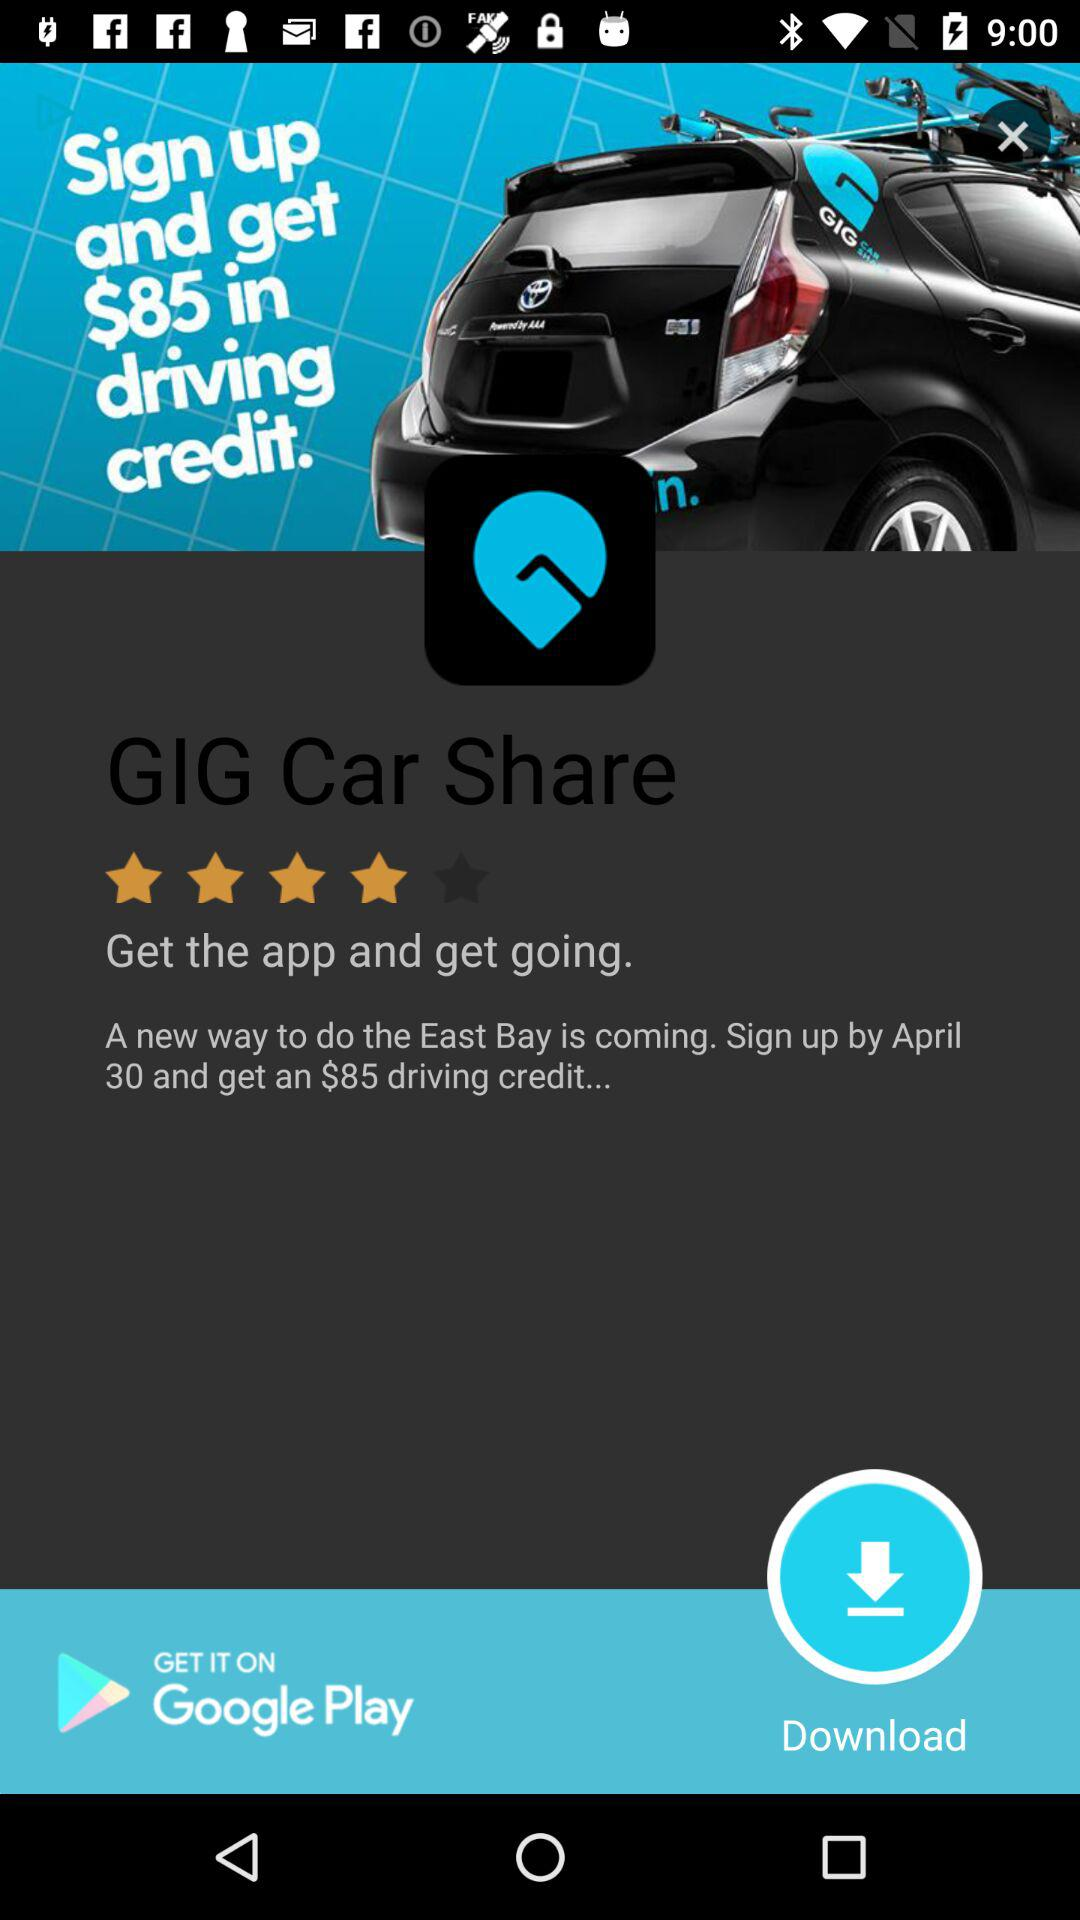What is the app name? The app name is "GIG Car Share". 